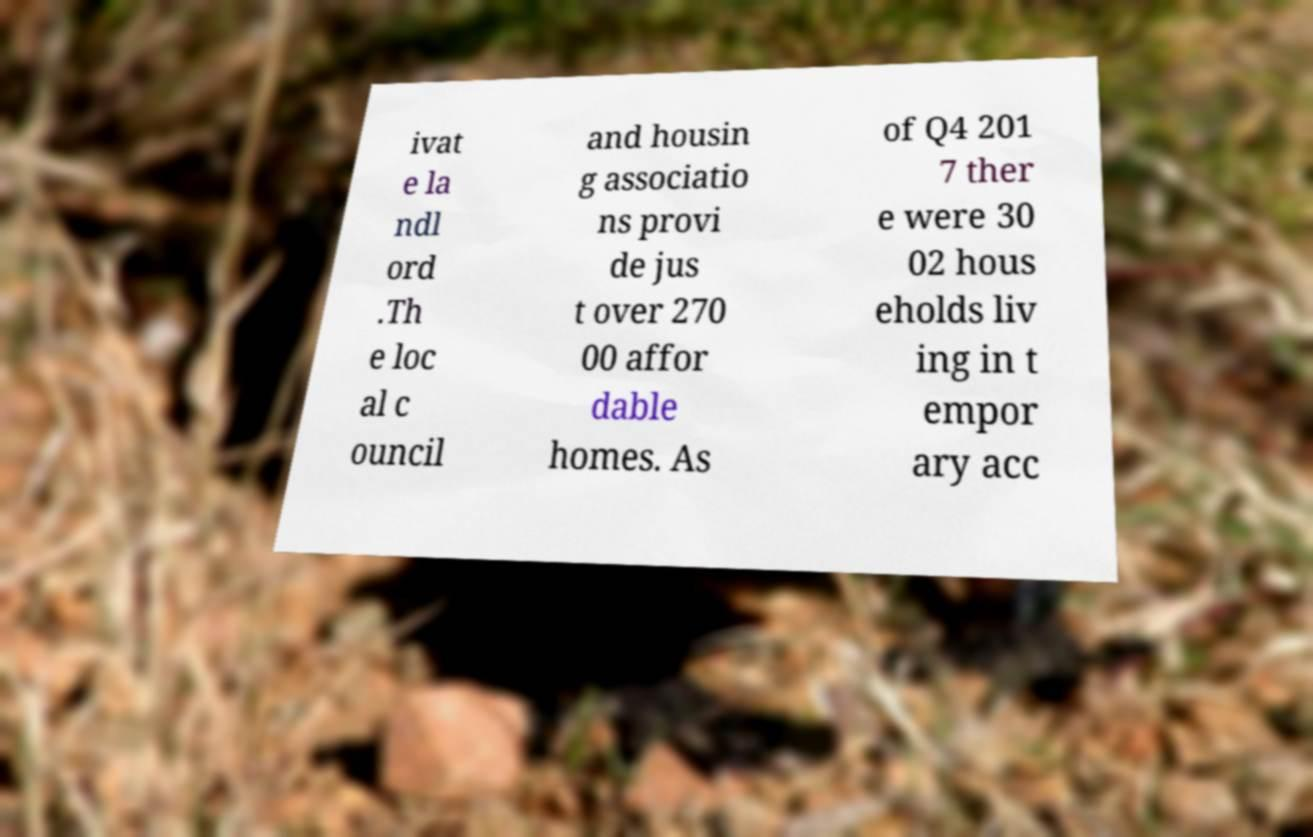Could you extract and type out the text from this image? ivat e la ndl ord .Th e loc al c ouncil and housin g associatio ns provi de jus t over 270 00 affor dable homes. As of Q4 201 7 ther e were 30 02 hous eholds liv ing in t empor ary acc 